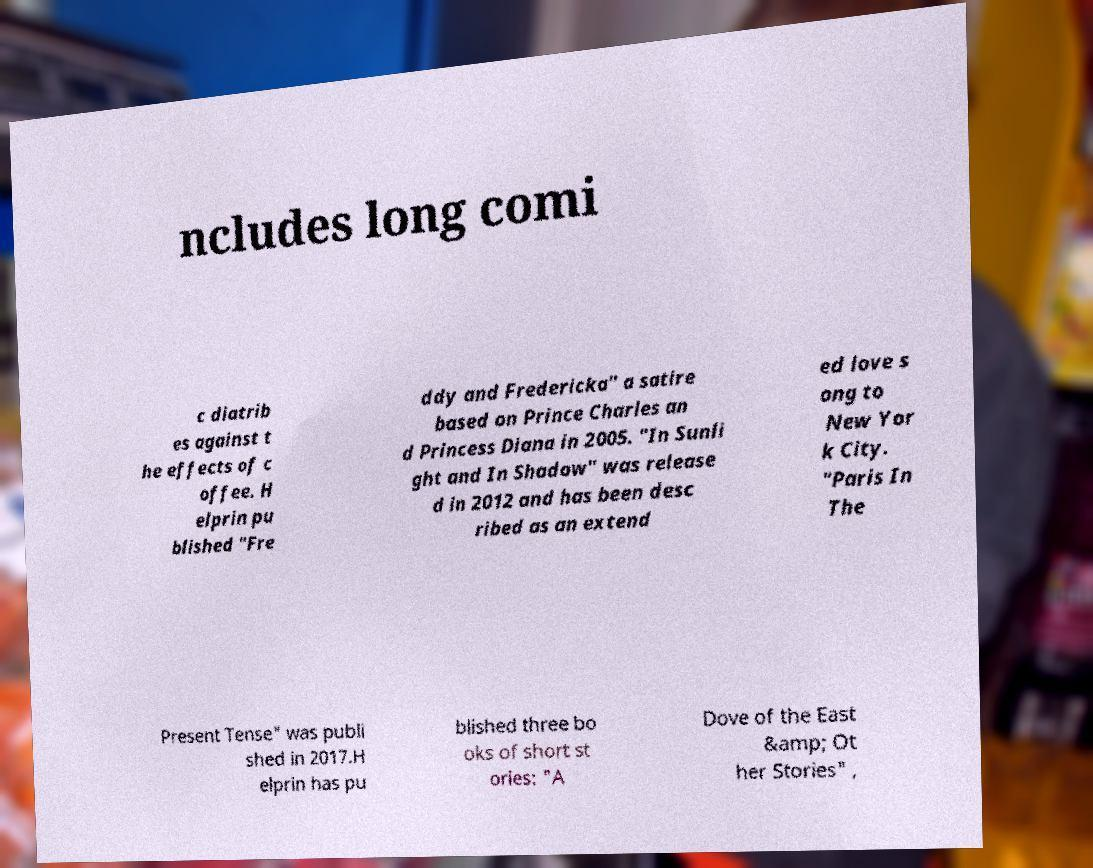Could you extract and type out the text from this image? ncludes long comi c diatrib es against t he effects of c offee. H elprin pu blished "Fre ddy and Fredericka" a satire based on Prince Charles an d Princess Diana in 2005. "In Sunli ght and In Shadow" was release d in 2012 and has been desc ribed as an extend ed love s ong to New Yor k City. "Paris In The Present Tense" was publi shed in 2017.H elprin has pu blished three bo oks of short st ories: "A Dove of the East &amp; Ot her Stories" , 